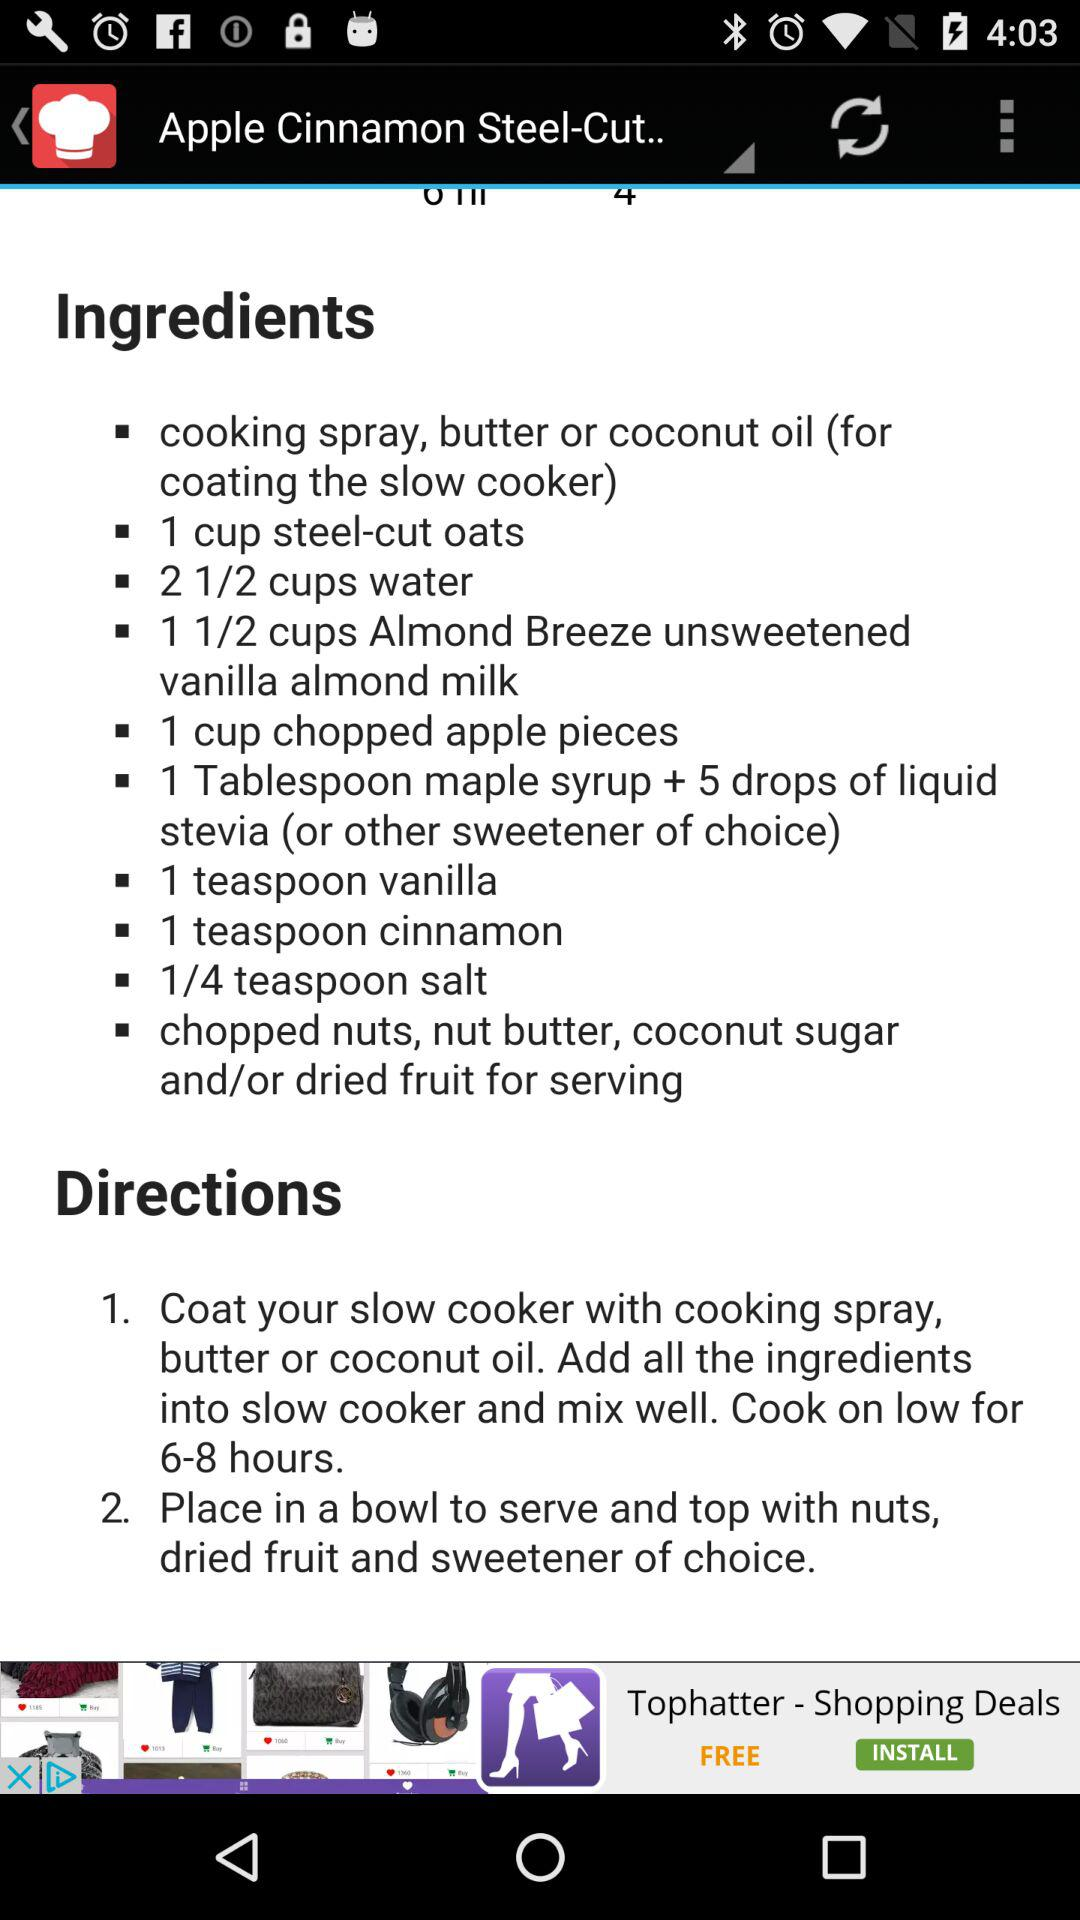What are the directions to make the recipe? The directions to make the recipe are to "Coat your slow cooker with cooking spray, butter or coconut oil. Add all the ingredients into slow cooker and mix well. Cook on low for 6-8 hours" and "Place in a bowl to serve and top with nuts, dried fruit and sweetener of choice". 